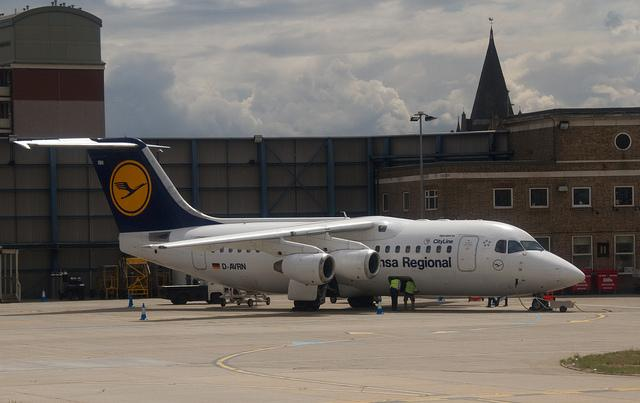What company owns this vehicle? Please explain your reasoning. lufthansa. The company is emblazoned on the side of the plane. 